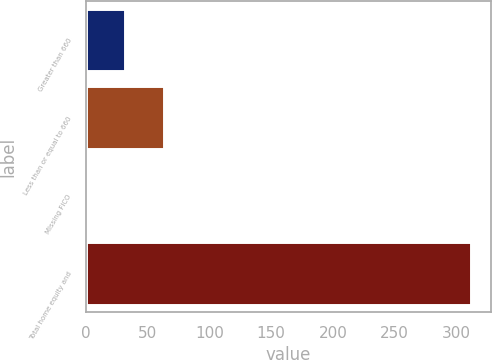<chart> <loc_0><loc_0><loc_500><loc_500><bar_chart><fcel>Greater than 660<fcel>Less than or equal to 660<fcel>Missing FICO<fcel>Total home equity and<nl><fcel>32.1<fcel>63.2<fcel>1<fcel>312<nl></chart> 